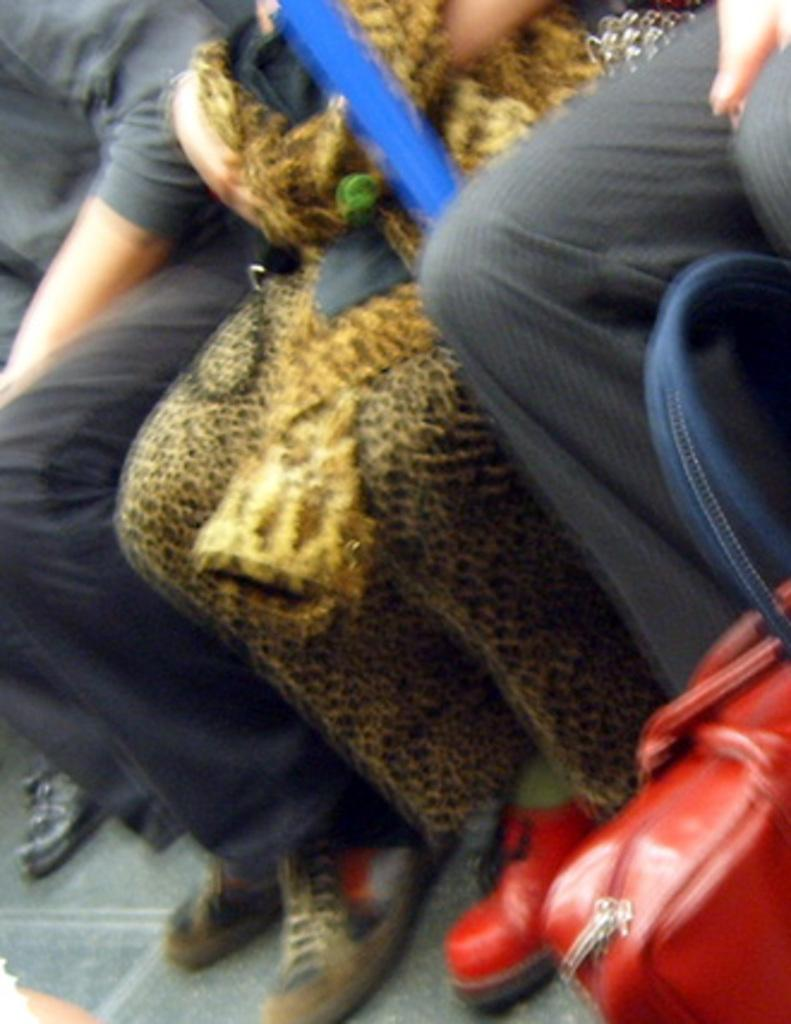What body parts are visible in the image? There are people's legs visible in the image. What object is in front of the legs? There is a red handbag in front of the legs. Where is the key to the park located in the image? There is no key or park mentioned in the image; it only features people's legs and a red handbag. 